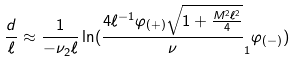Convert formula to latex. <formula><loc_0><loc_0><loc_500><loc_500>\frac { d } { \ell } \approx \frac { 1 } { - \nu _ { 2 } \ell } \ln ( \frac { 4 \ell ^ { - 1 } \varphi _ { ( + ) } \sqrt { 1 + \frac { M ^ { 2 } \ell ^ { 2 } } { 4 } } } \nu _ { 1 } \varphi _ { ( - ) } )</formula> 